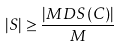<formula> <loc_0><loc_0><loc_500><loc_500>| S | \geq \frac { | M D S ( C ) | } { M }</formula> 